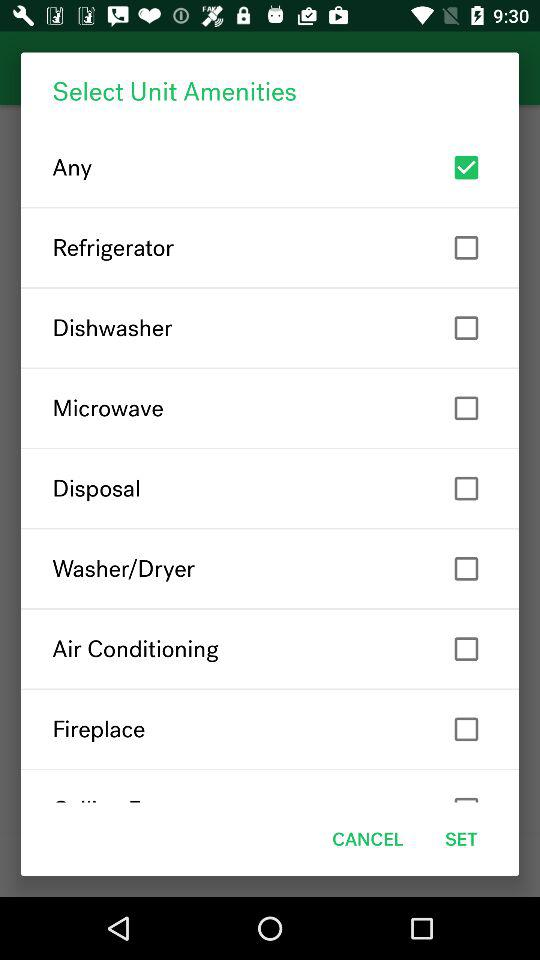What is the checked checkbox? The checked checkbox is "Any". 